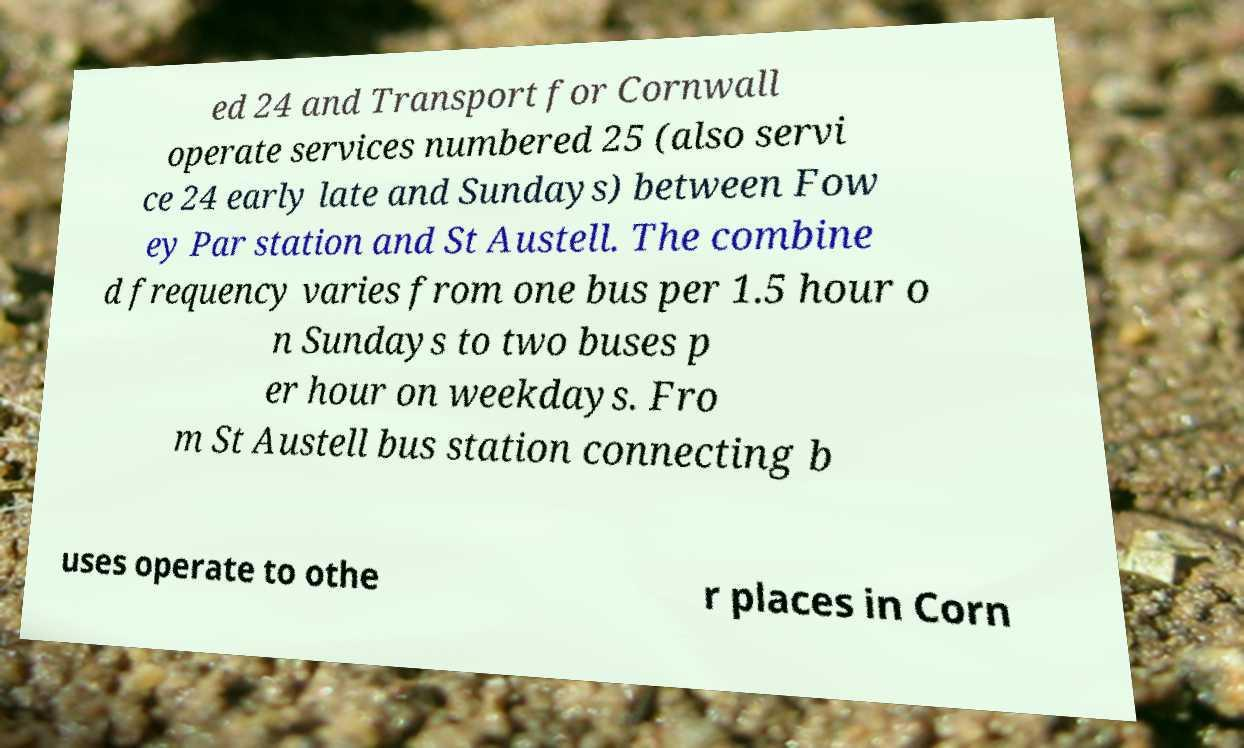There's text embedded in this image that I need extracted. Can you transcribe it verbatim? ed 24 and Transport for Cornwall operate services numbered 25 (also servi ce 24 early late and Sundays) between Fow ey Par station and St Austell. The combine d frequency varies from one bus per 1.5 hour o n Sundays to two buses p er hour on weekdays. Fro m St Austell bus station connecting b uses operate to othe r places in Corn 